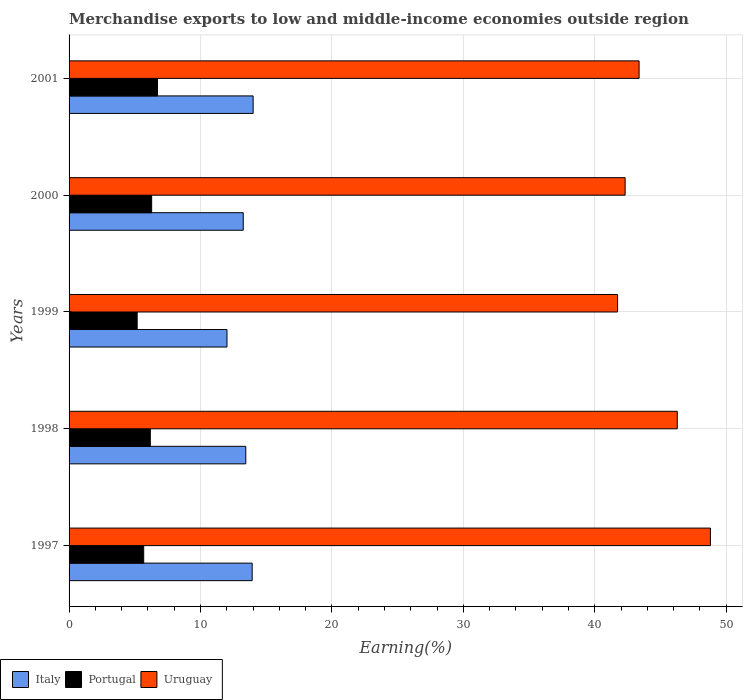How many different coloured bars are there?
Ensure brevity in your answer.  3. How many groups of bars are there?
Your answer should be very brief. 5. Are the number of bars on each tick of the Y-axis equal?
Offer a terse response. Yes. How many bars are there on the 1st tick from the bottom?
Offer a very short reply. 3. In how many cases, is the number of bars for a given year not equal to the number of legend labels?
Offer a terse response. 0. What is the percentage of amount earned from merchandise exports in Italy in 2000?
Provide a short and direct response. 13.25. Across all years, what is the maximum percentage of amount earned from merchandise exports in Uruguay?
Ensure brevity in your answer.  48.81. Across all years, what is the minimum percentage of amount earned from merchandise exports in Uruguay?
Your answer should be compact. 41.74. In which year was the percentage of amount earned from merchandise exports in Portugal maximum?
Give a very brief answer. 2001. What is the total percentage of amount earned from merchandise exports in Portugal in the graph?
Your answer should be very brief. 30.05. What is the difference between the percentage of amount earned from merchandise exports in Uruguay in 1999 and that in 2001?
Provide a short and direct response. -1.64. What is the difference between the percentage of amount earned from merchandise exports in Italy in 2000 and the percentage of amount earned from merchandise exports in Uruguay in 1999?
Your answer should be very brief. -28.49. What is the average percentage of amount earned from merchandise exports in Uruguay per year?
Make the answer very short. 44.5. In the year 1999, what is the difference between the percentage of amount earned from merchandise exports in Uruguay and percentage of amount earned from merchandise exports in Portugal?
Give a very brief answer. 36.56. What is the ratio of the percentage of amount earned from merchandise exports in Uruguay in 2000 to that in 2001?
Ensure brevity in your answer.  0.98. Is the percentage of amount earned from merchandise exports in Uruguay in 1998 less than that in 1999?
Provide a succinct answer. No. Is the difference between the percentage of amount earned from merchandise exports in Uruguay in 1998 and 1999 greater than the difference between the percentage of amount earned from merchandise exports in Portugal in 1998 and 1999?
Ensure brevity in your answer.  Yes. What is the difference between the highest and the second highest percentage of amount earned from merchandise exports in Portugal?
Ensure brevity in your answer.  0.44. What is the difference between the highest and the lowest percentage of amount earned from merchandise exports in Portugal?
Your answer should be very brief. 1.54. Is the sum of the percentage of amount earned from merchandise exports in Uruguay in 1997 and 1998 greater than the maximum percentage of amount earned from merchandise exports in Italy across all years?
Provide a succinct answer. Yes. How many bars are there?
Offer a very short reply. 15. What is the difference between two consecutive major ticks on the X-axis?
Your answer should be compact. 10. Does the graph contain any zero values?
Make the answer very short. No. Does the graph contain grids?
Give a very brief answer. Yes. Where does the legend appear in the graph?
Your answer should be very brief. Bottom left. How many legend labels are there?
Provide a succinct answer. 3. How are the legend labels stacked?
Provide a short and direct response. Horizontal. What is the title of the graph?
Offer a very short reply. Merchandise exports to low and middle-income economies outside region. What is the label or title of the X-axis?
Your response must be concise. Earning(%). What is the Earning(%) in Italy in 1997?
Your response must be concise. 13.93. What is the Earning(%) of Portugal in 1997?
Your response must be concise. 5.68. What is the Earning(%) of Uruguay in 1997?
Ensure brevity in your answer.  48.81. What is the Earning(%) of Italy in 1998?
Offer a terse response. 13.45. What is the Earning(%) of Portugal in 1998?
Your answer should be very brief. 6.18. What is the Earning(%) of Uruguay in 1998?
Ensure brevity in your answer.  46.28. What is the Earning(%) in Italy in 1999?
Offer a terse response. 12.02. What is the Earning(%) of Portugal in 1999?
Give a very brief answer. 5.18. What is the Earning(%) in Uruguay in 1999?
Give a very brief answer. 41.74. What is the Earning(%) of Italy in 2000?
Provide a short and direct response. 13.25. What is the Earning(%) of Portugal in 2000?
Keep it short and to the point. 6.28. What is the Earning(%) of Uruguay in 2000?
Your response must be concise. 42.31. What is the Earning(%) of Italy in 2001?
Provide a short and direct response. 14.01. What is the Earning(%) in Portugal in 2001?
Make the answer very short. 6.73. What is the Earning(%) in Uruguay in 2001?
Give a very brief answer. 43.38. Across all years, what is the maximum Earning(%) of Italy?
Provide a short and direct response. 14.01. Across all years, what is the maximum Earning(%) in Portugal?
Offer a very short reply. 6.73. Across all years, what is the maximum Earning(%) in Uruguay?
Offer a terse response. 48.81. Across all years, what is the minimum Earning(%) of Italy?
Keep it short and to the point. 12.02. Across all years, what is the minimum Earning(%) in Portugal?
Keep it short and to the point. 5.18. Across all years, what is the minimum Earning(%) in Uruguay?
Keep it short and to the point. 41.74. What is the total Earning(%) in Italy in the graph?
Give a very brief answer. 66.66. What is the total Earning(%) in Portugal in the graph?
Your answer should be compact. 30.05. What is the total Earning(%) in Uruguay in the graph?
Provide a succinct answer. 222.52. What is the difference between the Earning(%) in Italy in 1997 and that in 1998?
Keep it short and to the point. 0.49. What is the difference between the Earning(%) of Portugal in 1997 and that in 1998?
Your answer should be very brief. -0.5. What is the difference between the Earning(%) of Uruguay in 1997 and that in 1998?
Your answer should be compact. 2.52. What is the difference between the Earning(%) in Italy in 1997 and that in 1999?
Your response must be concise. 1.92. What is the difference between the Earning(%) of Portugal in 1997 and that in 1999?
Your answer should be compact. 0.5. What is the difference between the Earning(%) of Uruguay in 1997 and that in 1999?
Provide a short and direct response. 7.07. What is the difference between the Earning(%) in Italy in 1997 and that in 2000?
Give a very brief answer. 0.68. What is the difference between the Earning(%) in Portugal in 1997 and that in 2000?
Ensure brevity in your answer.  -0.61. What is the difference between the Earning(%) of Uruguay in 1997 and that in 2000?
Provide a succinct answer. 6.49. What is the difference between the Earning(%) of Italy in 1997 and that in 2001?
Offer a very short reply. -0.07. What is the difference between the Earning(%) of Portugal in 1997 and that in 2001?
Give a very brief answer. -1.05. What is the difference between the Earning(%) in Uruguay in 1997 and that in 2001?
Ensure brevity in your answer.  5.43. What is the difference between the Earning(%) in Italy in 1998 and that in 1999?
Your answer should be very brief. 1.43. What is the difference between the Earning(%) in Uruguay in 1998 and that in 1999?
Your response must be concise. 4.54. What is the difference between the Earning(%) in Italy in 1998 and that in 2000?
Provide a short and direct response. 0.19. What is the difference between the Earning(%) of Portugal in 1998 and that in 2000?
Your answer should be compact. -0.1. What is the difference between the Earning(%) of Uruguay in 1998 and that in 2000?
Your answer should be compact. 3.97. What is the difference between the Earning(%) of Italy in 1998 and that in 2001?
Your response must be concise. -0.56. What is the difference between the Earning(%) in Portugal in 1998 and that in 2001?
Keep it short and to the point. -0.54. What is the difference between the Earning(%) in Uruguay in 1998 and that in 2001?
Offer a very short reply. 2.9. What is the difference between the Earning(%) of Italy in 1999 and that in 2000?
Keep it short and to the point. -1.24. What is the difference between the Earning(%) of Portugal in 1999 and that in 2000?
Offer a terse response. -1.1. What is the difference between the Earning(%) of Uruguay in 1999 and that in 2000?
Offer a very short reply. -0.57. What is the difference between the Earning(%) in Italy in 1999 and that in 2001?
Give a very brief answer. -1.99. What is the difference between the Earning(%) in Portugal in 1999 and that in 2001?
Provide a succinct answer. -1.54. What is the difference between the Earning(%) in Uruguay in 1999 and that in 2001?
Make the answer very short. -1.64. What is the difference between the Earning(%) of Italy in 2000 and that in 2001?
Your answer should be compact. -0.75. What is the difference between the Earning(%) in Portugal in 2000 and that in 2001?
Keep it short and to the point. -0.44. What is the difference between the Earning(%) of Uruguay in 2000 and that in 2001?
Your answer should be compact. -1.06. What is the difference between the Earning(%) in Italy in 1997 and the Earning(%) in Portugal in 1998?
Keep it short and to the point. 7.75. What is the difference between the Earning(%) of Italy in 1997 and the Earning(%) of Uruguay in 1998?
Make the answer very short. -32.35. What is the difference between the Earning(%) of Portugal in 1997 and the Earning(%) of Uruguay in 1998?
Offer a very short reply. -40.6. What is the difference between the Earning(%) of Italy in 1997 and the Earning(%) of Portugal in 1999?
Your answer should be compact. 8.75. What is the difference between the Earning(%) in Italy in 1997 and the Earning(%) in Uruguay in 1999?
Give a very brief answer. -27.81. What is the difference between the Earning(%) in Portugal in 1997 and the Earning(%) in Uruguay in 1999?
Ensure brevity in your answer.  -36.06. What is the difference between the Earning(%) in Italy in 1997 and the Earning(%) in Portugal in 2000?
Give a very brief answer. 7.65. What is the difference between the Earning(%) in Italy in 1997 and the Earning(%) in Uruguay in 2000?
Your answer should be compact. -28.38. What is the difference between the Earning(%) of Portugal in 1997 and the Earning(%) of Uruguay in 2000?
Ensure brevity in your answer.  -36.63. What is the difference between the Earning(%) in Italy in 1997 and the Earning(%) in Portugal in 2001?
Provide a short and direct response. 7.21. What is the difference between the Earning(%) of Italy in 1997 and the Earning(%) of Uruguay in 2001?
Keep it short and to the point. -29.44. What is the difference between the Earning(%) of Portugal in 1997 and the Earning(%) of Uruguay in 2001?
Keep it short and to the point. -37.7. What is the difference between the Earning(%) of Italy in 1998 and the Earning(%) of Portugal in 1999?
Offer a terse response. 8.26. What is the difference between the Earning(%) of Italy in 1998 and the Earning(%) of Uruguay in 1999?
Your answer should be compact. -28.29. What is the difference between the Earning(%) in Portugal in 1998 and the Earning(%) in Uruguay in 1999?
Your answer should be very brief. -35.56. What is the difference between the Earning(%) in Italy in 1998 and the Earning(%) in Portugal in 2000?
Give a very brief answer. 7.16. What is the difference between the Earning(%) in Italy in 1998 and the Earning(%) in Uruguay in 2000?
Your answer should be compact. -28.87. What is the difference between the Earning(%) in Portugal in 1998 and the Earning(%) in Uruguay in 2000?
Provide a succinct answer. -36.13. What is the difference between the Earning(%) in Italy in 1998 and the Earning(%) in Portugal in 2001?
Give a very brief answer. 6.72. What is the difference between the Earning(%) in Italy in 1998 and the Earning(%) in Uruguay in 2001?
Your answer should be very brief. -29.93. What is the difference between the Earning(%) in Portugal in 1998 and the Earning(%) in Uruguay in 2001?
Make the answer very short. -37.2. What is the difference between the Earning(%) in Italy in 1999 and the Earning(%) in Portugal in 2000?
Offer a terse response. 5.73. What is the difference between the Earning(%) of Italy in 1999 and the Earning(%) of Uruguay in 2000?
Offer a very short reply. -30.3. What is the difference between the Earning(%) in Portugal in 1999 and the Earning(%) in Uruguay in 2000?
Make the answer very short. -37.13. What is the difference between the Earning(%) in Italy in 1999 and the Earning(%) in Portugal in 2001?
Ensure brevity in your answer.  5.29. What is the difference between the Earning(%) of Italy in 1999 and the Earning(%) of Uruguay in 2001?
Your answer should be very brief. -31.36. What is the difference between the Earning(%) in Portugal in 1999 and the Earning(%) in Uruguay in 2001?
Offer a terse response. -38.19. What is the difference between the Earning(%) in Italy in 2000 and the Earning(%) in Portugal in 2001?
Give a very brief answer. 6.53. What is the difference between the Earning(%) in Italy in 2000 and the Earning(%) in Uruguay in 2001?
Offer a terse response. -30.12. What is the difference between the Earning(%) in Portugal in 2000 and the Earning(%) in Uruguay in 2001?
Ensure brevity in your answer.  -37.09. What is the average Earning(%) of Italy per year?
Provide a short and direct response. 13.33. What is the average Earning(%) in Portugal per year?
Offer a very short reply. 6.01. What is the average Earning(%) in Uruguay per year?
Offer a very short reply. 44.5. In the year 1997, what is the difference between the Earning(%) in Italy and Earning(%) in Portugal?
Make the answer very short. 8.25. In the year 1997, what is the difference between the Earning(%) in Italy and Earning(%) in Uruguay?
Make the answer very short. -34.87. In the year 1997, what is the difference between the Earning(%) of Portugal and Earning(%) of Uruguay?
Your answer should be very brief. -43.13. In the year 1998, what is the difference between the Earning(%) in Italy and Earning(%) in Portugal?
Offer a terse response. 7.27. In the year 1998, what is the difference between the Earning(%) of Italy and Earning(%) of Uruguay?
Your response must be concise. -32.83. In the year 1998, what is the difference between the Earning(%) of Portugal and Earning(%) of Uruguay?
Ensure brevity in your answer.  -40.1. In the year 1999, what is the difference between the Earning(%) of Italy and Earning(%) of Portugal?
Your answer should be compact. 6.83. In the year 1999, what is the difference between the Earning(%) of Italy and Earning(%) of Uruguay?
Give a very brief answer. -29.72. In the year 1999, what is the difference between the Earning(%) in Portugal and Earning(%) in Uruguay?
Provide a succinct answer. -36.56. In the year 2000, what is the difference between the Earning(%) of Italy and Earning(%) of Portugal?
Make the answer very short. 6.97. In the year 2000, what is the difference between the Earning(%) of Italy and Earning(%) of Uruguay?
Your answer should be compact. -29.06. In the year 2000, what is the difference between the Earning(%) of Portugal and Earning(%) of Uruguay?
Your answer should be compact. -36.03. In the year 2001, what is the difference between the Earning(%) of Italy and Earning(%) of Portugal?
Keep it short and to the point. 7.28. In the year 2001, what is the difference between the Earning(%) in Italy and Earning(%) in Uruguay?
Make the answer very short. -29.37. In the year 2001, what is the difference between the Earning(%) in Portugal and Earning(%) in Uruguay?
Provide a short and direct response. -36.65. What is the ratio of the Earning(%) in Italy in 1997 to that in 1998?
Offer a very short reply. 1.04. What is the ratio of the Earning(%) of Portugal in 1997 to that in 1998?
Provide a succinct answer. 0.92. What is the ratio of the Earning(%) in Uruguay in 1997 to that in 1998?
Keep it short and to the point. 1.05. What is the ratio of the Earning(%) of Italy in 1997 to that in 1999?
Make the answer very short. 1.16. What is the ratio of the Earning(%) of Portugal in 1997 to that in 1999?
Provide a short and direct response. 1.1. What is the ratio of the Earning(%) of Uruguay in 1997 to that in 1999?
Keep it short and to the point. 1.17. What is the ratio of the Earning(%) in Italy in 1997 to that in 2000?
Provide a succinct answer. 1.05. What is the ratio of the Earning(%) in Portugal in 1997 to that in 2000?
Offer a very short reply. 0.9. What is the ratio of the Earning(%) of Uruguay in 1997 to that in 2000?
Your answer should be compact. 1.15. What is the ratio of the Earning(%) of Portugal in 1997 to that in 2001?
Ensure brevity in your answer.  0.84. What is the ratio of the Earning(%) in Uruguay in 1997 to that in 2001?
Offer a terse response. 1.13. What is the ratio of the Earning(%) in Italy in 1998 to that in 1999?
Your response must be concise. 1.12. What is the ratio of the Earning(%) in Portugal in 1998 to that in 1999?
Offer a very short reply. 1.19. What is the ratio of the Earning(%) in Uruguay in 1998 to that in 1999?
Your answer should be compact. 1.11. What is the ratio of the Earning(%) in Italy in 1998 to that in 2000?
Offer a very short reply. 1.01. What is the ratio of the Earning(%) in Portugal in 1998 to that in 2000?
Give a very brief answer. 0.98. What is the ratio of the Earning(%) of Uruguay in 1998 to that in 2000?
Your answer should be compact. 1.09. What is the ratio of the Earning(%) of Italy in 1998 to that in 2001?
Provide a short and direct response. 0.96. What is the ratio of the Earning(%) of Portugal in 1998 to that in 2001?
Your answer should be very brief. 0.92. What is the ratio of the Earning(%) in Uruguay in 1998 to that in 2001?
Ensure brevity in your answer.  1.07. What is the ratio of the Earning(%) of Italy in 1999 to that in 2000?
Keep it short and to the point. 0.91. What is the ratio of the Earning(%) of Portugal in 1999 to that in 2000?
Keep it short and to the point. 0.82. What is the ratio of the Earning(%) in Uruguay in 1999 to that in 2000?
Make the answer very short. 0.99. What is the ratio of the Earning(%) in Italy in 1999 to that in 2001?
Provide a short and direct response. 0.86. What is the ratio of the Earning(%) in Portugal in 1999 to that in 2001?
Your response must be concise. 0.77. What is the ratio of the Earning(%) of Uruguay in 1999 to that in 2001?
Keep it short and to the point. 0.96. What is the ratio of the Earning(%) in Italy in 2000 to that in 2001?
Offer a terse response. 0.95. What is the ratio of the Earning(%) in Portugal in 2000 to that in 2001?
Your answer should be very brief. 0.93. What is the ratio of the Earning(%) in Uruguay in 2000 to that in 2001?
Offer a terse response. 0.98. What is the difference between the highest and the second highest Earning(%) in Italy?
Provide a succinct answer. 0.07. What is the difference between the highest and the second highest Earning(%) of Portugal?
Ensure brevity in your answer.  0.44. What is the difference between the highest and the second highest Earning(%) in Uruguay?
Provide a succinct answer. 2.52. What is the difference between the highest and the lowest Earning(%) of Italy?
Ensure brevity in your answer.  1.99. What is the difference between the highest and the lowest Earning(%) of Portugal?
Ensure brevity in your answer.  1.54. What is the difference between the highest and the lowest Earning(%) of Uruguay?
Make the answer very short. 7.07. 